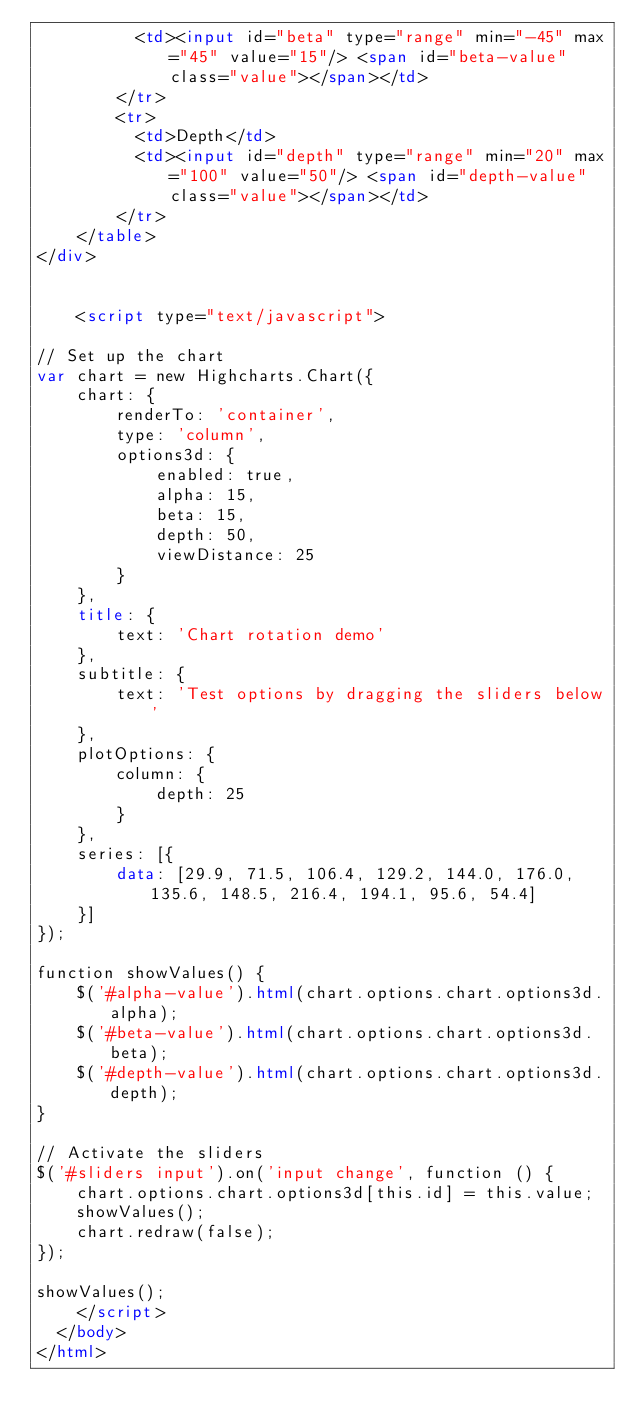<code> <loc_0><loc_0><loc_500><loc_500><_HTML_>        	<td><input id="beta" type="range" min="-45" max="45" value="15"/> <span id="beta-value" class="value"></span></td>
        </tr>
        <tr>
        	<td>Depth</td>
        	<td><input id="depth" type="range" min="20" max="100" value="50"/> <span id="depth-value" class="value"></span></td>
        </tr>
    </table>
</div>


		<script type="text/javascript">

// Set up the chart
var chart = new Highcharts.Chart({
    chart: {
        renderTo: 'container',
        type: 'column',
        options3d: {
            enabled: true,
            alpha: 15,
            beta: 15,
            depth: 50,
            viewDistance: 25
        }
    },
    title: {
        text: 'Chart rotation demo'
    },
    subtitle: {
        text: 'Test options by dragging the sliders below'
    },
    plotOptions: {
        column: {
            depth: 25
        }
    },
    series: [{
        data: [29.9, 71.5, 106.4, 129.2, 144.0, 176.0, 135.6, 148.5, 216.4, 194.1, 95.6, 54.4]
    }]
});

function showValues() {
    $('#alpha-value').html(chart.options.chart.options3d.alpha);
    $('#beta-value').html(chart.options.chart.options3d.beta);
    $('#depth-value').html(chart.options.chart.options3d.depth);
}

// Activate the sliders
$('#sliders input').on('input change', function () {
    chart.options.chart.options3d[this.id] = this.value;
    showValues();
    chart.redraw(false);
});

showValues();
		</script>
	</body>
</html>
</code> 